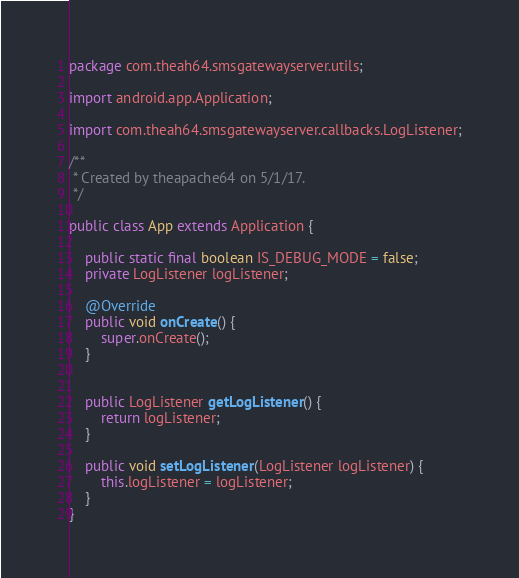<code> <loc_0><loc_0><loc_500><loc_500><_Java_>package com.theah64.smsgatewayserver.utils;

import android.app.Application;

import com.theah64.smsgatewayserver.callbacks.LogListener;

/**
 * Created by theapache64 on 5/1/17.
 */

public class App extends Application {

    public static final boolean IS_DEBUG_MODE = false;
    private LogListener logListener;

    @Override
    public void onCreate() {
        super.onCreate();
    }


    public LogListener getLogListener() {
        return logListener;
    }

    public void setLogListener(LogListener logListener) {
        this.logListener = logListener;
    }
}
</code> 